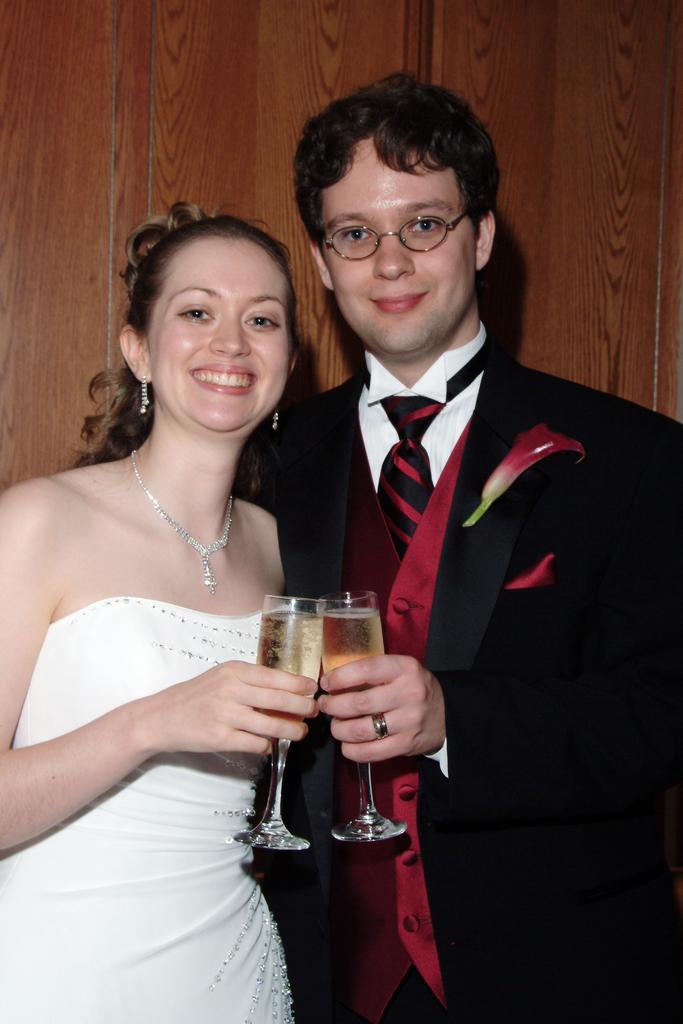Could you give a brief overview of what you see in this image? In this picture there are two persons, one woman and one man. Towards the left, woman is wearing a white dress and towards the right,man is wearing a black blazer. Both are holding glasses. 